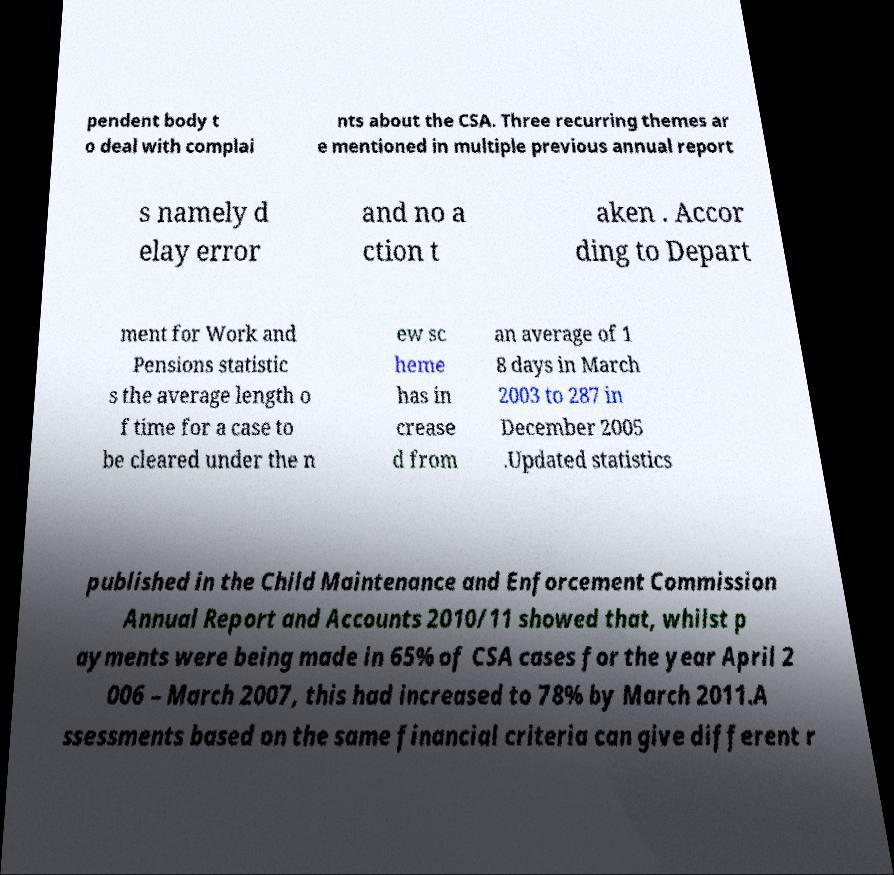Please read and relay the text visible in this image. What does it say? pendent body t o deal with complai nts about the CSA. Three recurring themes ar e mentioned in multiple previous annual report s namely d elay error and no a ction t aken . Accor ding to Depart ment for Work and Pensions statistic s the average length o f time for a case to be cleared under the n ew sc heme has in crease d from an average of 1 8 days in March 2003 to 287 in December 2005 .Updated statistics published in the Child Maintenance and Enforcement Commission Annual Report and Accounts 2010/11 showed that, whilst p ayments were being made in 65% of CSA cases for the year April 2 006 – March 2007, this had increased to 78% by March 2011.A ssessments based on the same financial criteria can give different r 